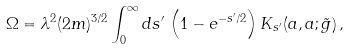Convert formula to latex. <formula><loc_0><loc_0><loc_500><loc_500>\Omega = \lambda ^ { 2 } ( 2 m ) ^ { 3 / 2 } \int _ { 0 } ^ { \infty } d s ^ { \prime } \, \left ( 1 - e ^ { - s ^ { \prime } / 2 } \right ) K _ { s ^ { \prime } } ( a , a ; \tilde { g } ) \, ,</formula> 